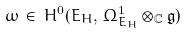Convert formula to latex. <formula><loc_0><loc_0><loc_500><loc_500>\omega \, \in \, H ^ { 0 } ( E _ { H } , \, \Omega ^ { 1 } _ { E _ { H } } \otimes _ { \mathbb { C } } { \mathfrak g } )</formula> 